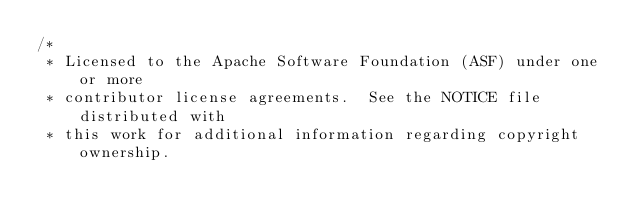Convert code to text. <code><loc_0><loc_0><loc_500><loc_500><_Scala_>/*
 * Licensed to the Apache Software Foundation (ASF) under one or more
 * contributor license agreements.  See the NOTICE file distributed with
 * this work for additional information regarding copyright ownership.</code> 